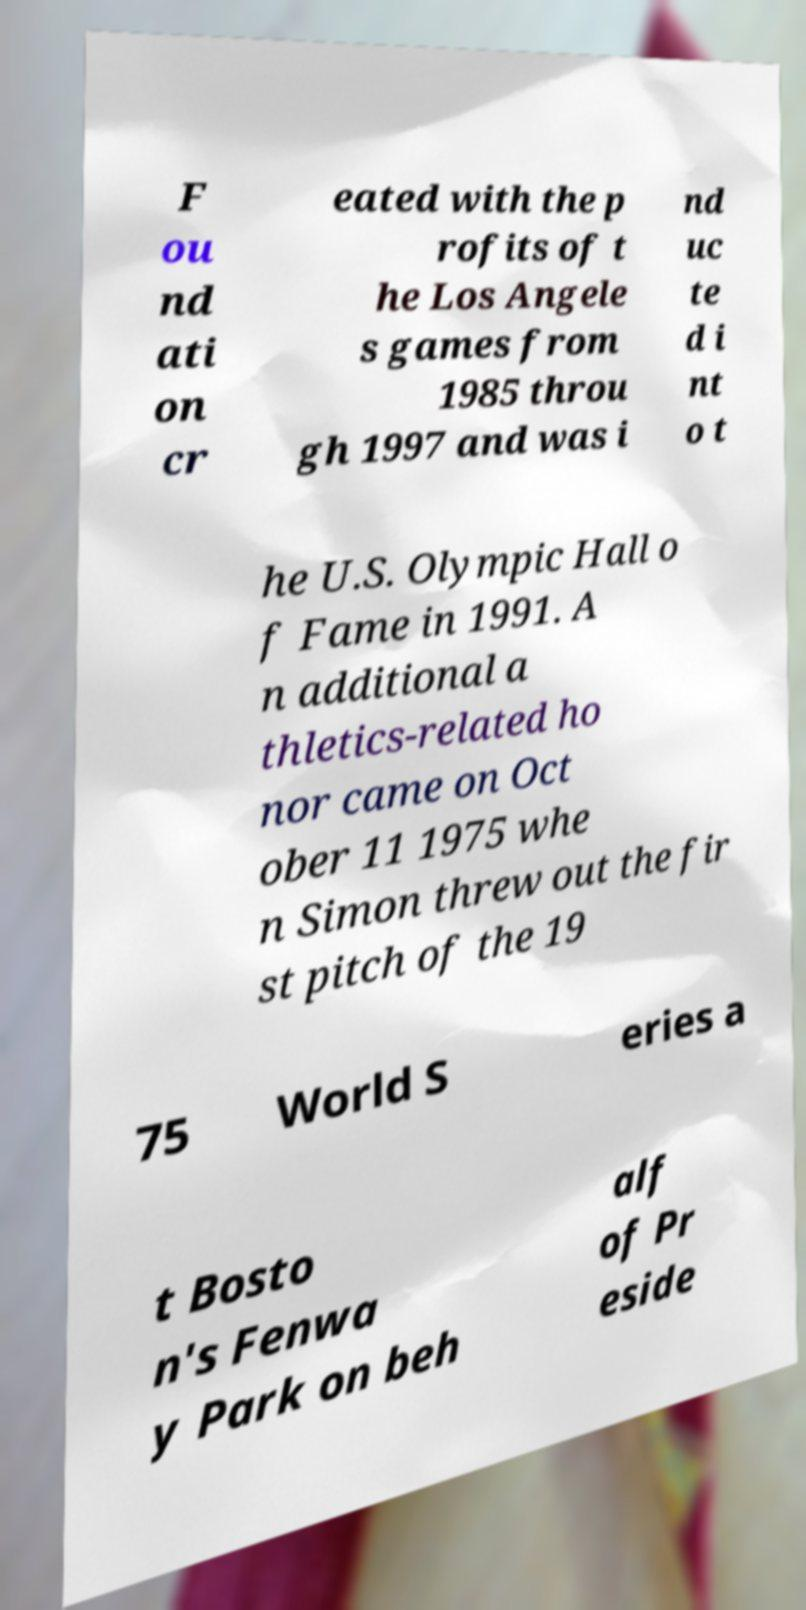Could you assist in decoding the text presented in this image and type it out clearly? F ou nd ati on cr eated with the p rofits of t he Los Angele s games from 1985 throu gh 1997 and was i nd uc te d i nt o t he U.S. Olympic Hall o f Fame in 1991. A n additional a thletics-related ho nor came on Oct ober 11 1975 whe n Simon threw out the fir st pitch of the 19 75 World S eries a t Bosto n's Fenwa y Park on beh alf of Pr eside 